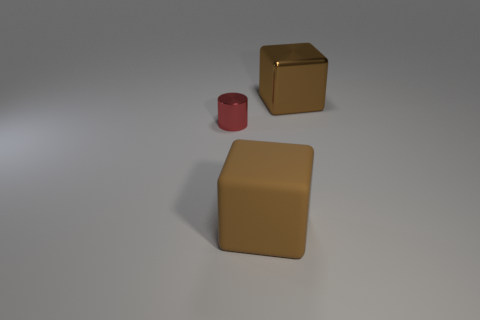How many objects are either large cyan rubber blocks or brown objects that are in front of the tiny metallic cylinder?
Keep it short and to the point. 1. Do the metal thing that is to the left of the brown rubber thing and the matte block have the same size?
Your answer should be compact. No. How many other things are there of the same shape as the red shiny object?
Offer a very short reply. 0. How many brown things are large matte things or shiny cylinders?
Provide a succinct answer. 1. There is a thing that is behind the tiny red cylinder; is its color the same as the large rubber cube?
Provide a short and direct response. Yes. There is a large brown thing that is made of the same material as the small thing; what is its shape?
Offer a very short reply. Cube. There is a object that is both behind the rubber thing and on the right side of the small red thing; what is its color?
Keep it short and to the point. Brown. There is a block that is in front of the big brown cube behind the tiny shiny cylinder; how big is it?
Ensure brevity in your answer.  Large. Are there any large metal objects that have the same color as the cylinder?
Offer a very short reply. No. Are there the same number of large brown rubber things left of the tiny red metallic cylinder and big rubber cubes?
Provide a short and direct response. No. 